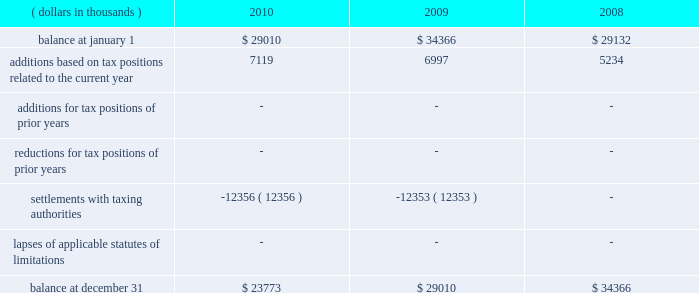A reconciliation of the beginning and ending amount of unrecognized tax benefits , for the periods indicated , is as follows: .
The entire amount of the unrecognized tax benefits would affect the effective tax rate if recognized .
In 2010 , the company favorably settled a 2003 and 2004 irs audit .
The company recorded a net overall tax benefit including accrued interest of $ 25920 thousand .
In addition , the company was also able to take down a $ 12356 thousand fin 48 reserve that had been established regarding the 2003 and 2004 irs audit .
The company is no longer subject to u.s .
Federal , state and local or foreign income tax examinations by tax authorities for years before 2007 .
The company recognizes accrued interest related to net unrecognized tax benefits and penalties in income taxes .
During the years ended december 31 , 2010 , 2009 and 2008 , the company accrued and recognized a net expense ( benefit ) of approximately $ ( 9938 ) thousand , $ 1563 thousand and $ 2446 thousand , respectively , in interest and penalties .
Included within the 2010 net expense ( benefit ) of $ ( 9938 ) thousand is $ ( 10591 ) thousand of accrued interest related to the 2003 and 2004 irs audit .
The company is not aware of any positions for which it is reasonably possible that the total amounts of unrecognized tax benefits will significantly increase or decrease within twelve months of the reporting date .
For u.s .
Income tax purposes the company has foreign tax credit carryforwards of $ 55026 thousand that begin to expire in 2014 .
In addition , for u.s .
Income tax purposes the company has $ 41693 thousand of alternative minimum tax credits that do not expire .
Management believes that it is more likely than not that the company will realize the benefits of its net deferred tax assets and , accordingly , no valuation allowance has been recorded for the periods presented .
Tax benefits of $ 629 thousand and $ 1714 thousand related to share-based compensation deductions for stock options exercised in 2010 and 2009 , respectively , are included within additional paid-in capital of the shareholders 2019 equity section of the consolidated balance sheets. .
In the 2010 , the company settled an audit agreement favorable . as a result of this favorable agreement , what might the balance be on december 1st? 
Rationale: the audit agreement that occurred released the losses of $ 12356 and brought in an increase of interest of $ 25920 which would make their net total be $ 62049 .
Computations: ((29010 + 7119) + 25920)
Answer: 62049.0. 